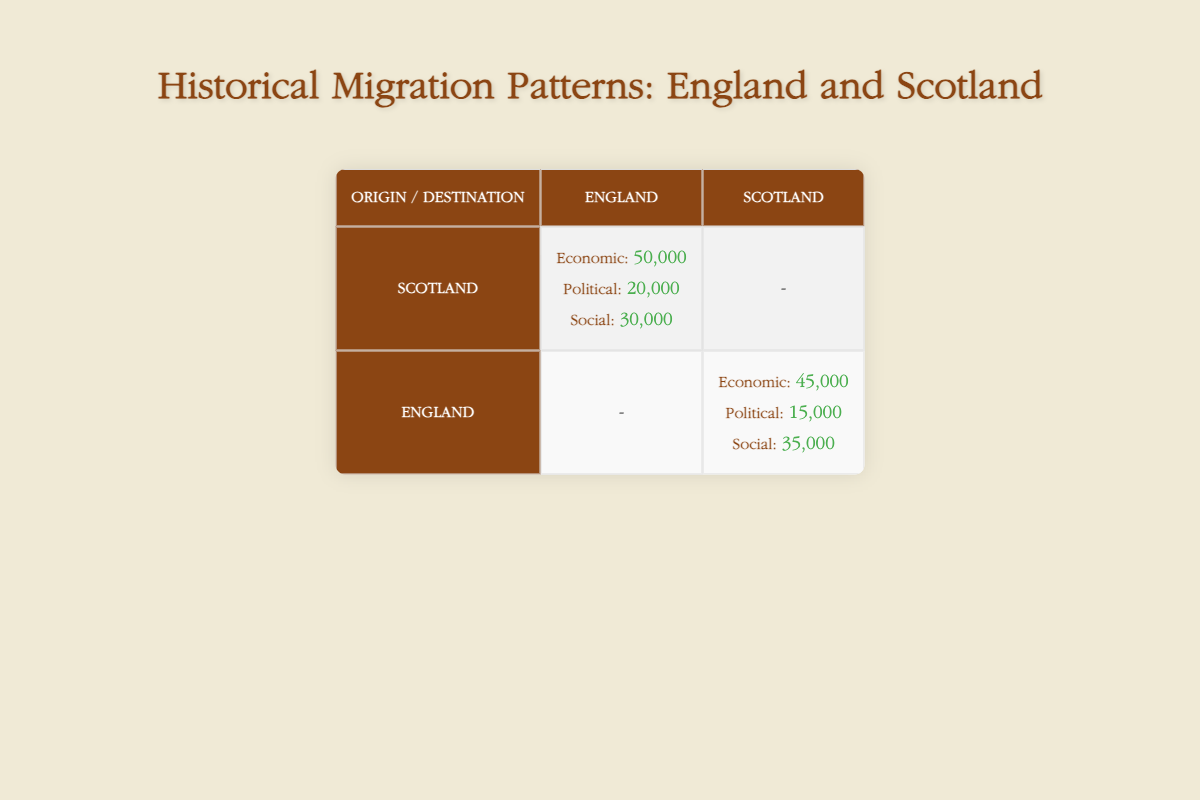What is the total count of economic migrations from Scotland to England? According to the table, the count for economic migrations from Scotland to England is explicitly stated as 50,000.
Answer: 50,000 How many social migrations occurred from England to Scotland? The table indicates that there were 35,000 social migrations from England to Scotland.
Answer: 35,000 Is the count of political migrations from Scotland to England greater than those from England to Scotland? From the table, Scotland to England political migrations count is 20,000 and England to Scotland political migrations count is 15,000. Since 20,000 is greater than 15,000, the statement is true.
Answer: Yes What is the combined total of all economic migrations between Scotland and England? The economic migration counts are 50,000 (Scotland to England) and 45,000 (England to Scotland). Adding them together gives 50,000 + 45,000 = 95,000.
Answer: 95,000 Which type of migration has the highest count from Scotland to England? By examining the table, the counts for migrations from Scotland to England are: economic (50,000), political (20,000), and social (30,000). The highest of these is economic with 50,000.
Answer: Economic What is the difference between the total social migrations from both countries? The total social migrations consist of 30,000 from Scotland to England and 35,000 from England to Scotland. The difference is calculated as 35,000 - 30,000 = 5,000, showing there are more migrations from England to Scotland.
Answer: 5,000 Are more people migrating from Scotland to England for economic reasons than for political reasons? The table shows 50,000 migrations for economic reasons and 20,000 for political reasons, indicating that economic migrations are indeed higher, so the statement is true.
Answer: Yes What is the average count of political migrations between Scotland and England? There are 20,000 political migrations from Scotland to England and 15,000 from England to Scotland. To find the average, we add these two values (20,000 + 15,000) = 35,000 and divide by 2, resulting in an average of 17,500.
Answer: 17,500 